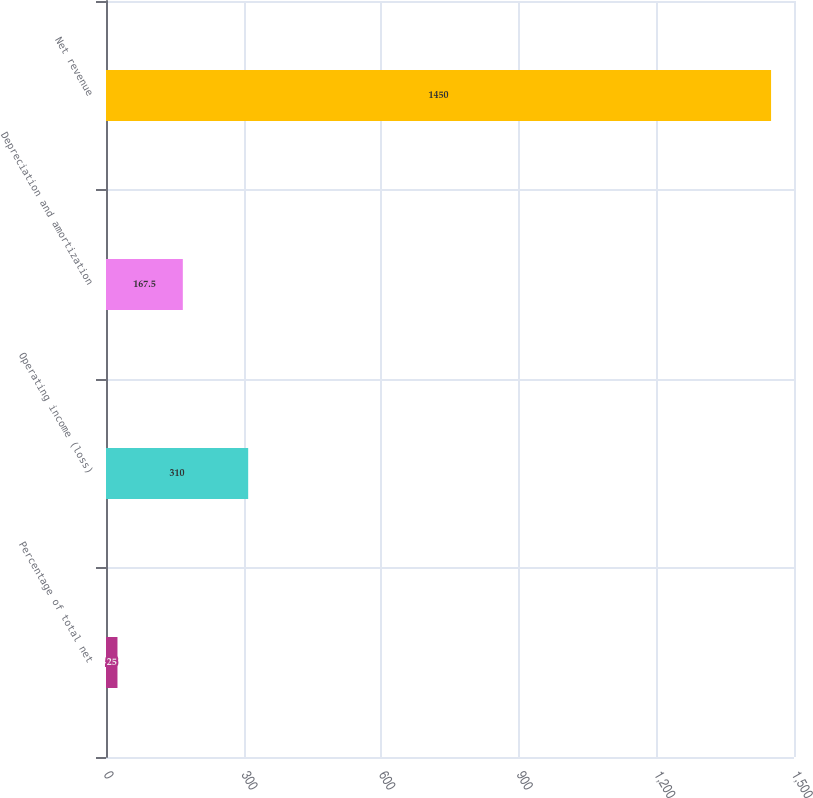<chart> <loc_0><loc_0><loc_500><loc_500><bar_chart><fcel>Percentage of total net<fcel>Operating income (loss)<fcel>Depreciation and amortization<fcel>Net revenue<nl><fcel>25<fcel>310<fcel>167.5<fcel>1450<nl></chart> 